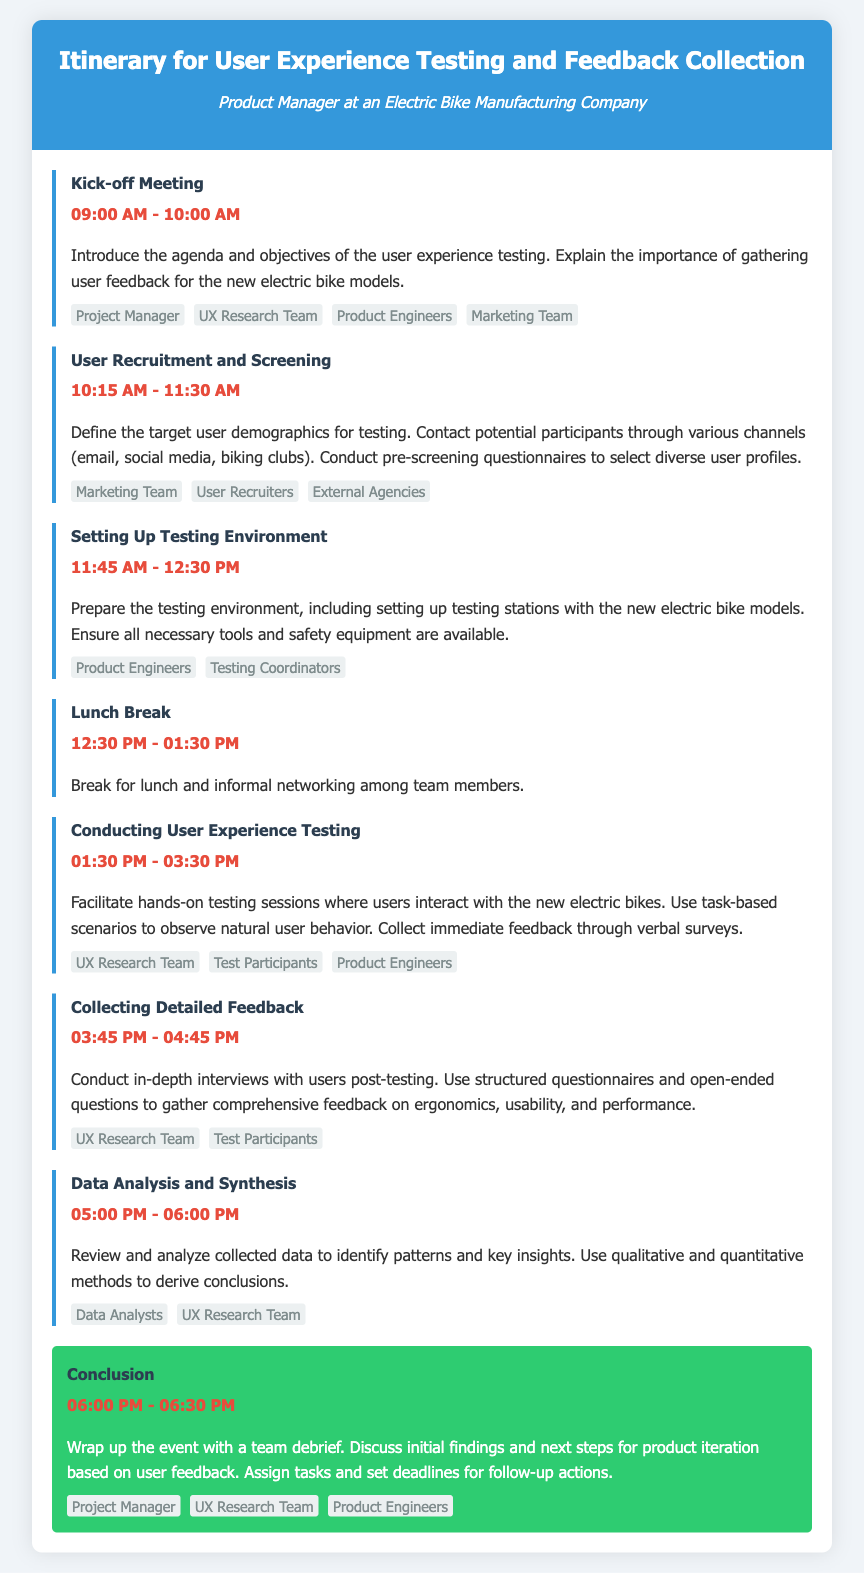What time is the Kick-off Meeting? The Kick-off Meeting takes place from 09:00 AM to 10:00 AM as mentioned in the itinerary.
Answer: 09:00 AM - 10:00 AM Who are the key entities involved in User Recruitment and Screening? The key entities are listed in the itinerary for User Recruitment and Screening, which includes the Marketing Team, User Recruiters, and External Agencies.
Answer: Marketing Team, User Recruiters, External Agencies What is the duration of the lunch break? The lunch break is specified as occurring from 12:30 PM to 01:30 PM, which indicates a duration of one hour.
Answer: 1 hour What occurs right after Conducting User Experience Testing? The next event listed after Conducting User Experience Testing is Collecting Detailed Feedback, which begins at 03:45 PM.
Answer: Collecting Detailed Feedback How many steps are there in the itinerary? Counting each unique step listed in the itinerary, there are a total of 7 steps outlined.
Answer: 7 steps Which team will conduct in-depth interviews with users? The team responsible for conducting in-depth interviews after testing is the UX Research Team, as stated in the itinerary.
Answer: UX Research Team What time does the conclusion wrap up the event? The Conclusion wraps up at 06:30 PM according to the schedule provided in the document.
Answer: 06:30 PM What is the primary focus of the Kick-off Meeting? The primary focus is to introduce the agenda and objectives of the user experience testing, emphasizing the importance of gathering user feedback.
Answer: User experience testing objectives What are the key activities during the Conducting User Experience Testing step? The activities include facilitating hands-on testing sessions, observing user behavior, and collecting immediate feedback through verbal surveys.
Answer: Hands-on testing sessions 